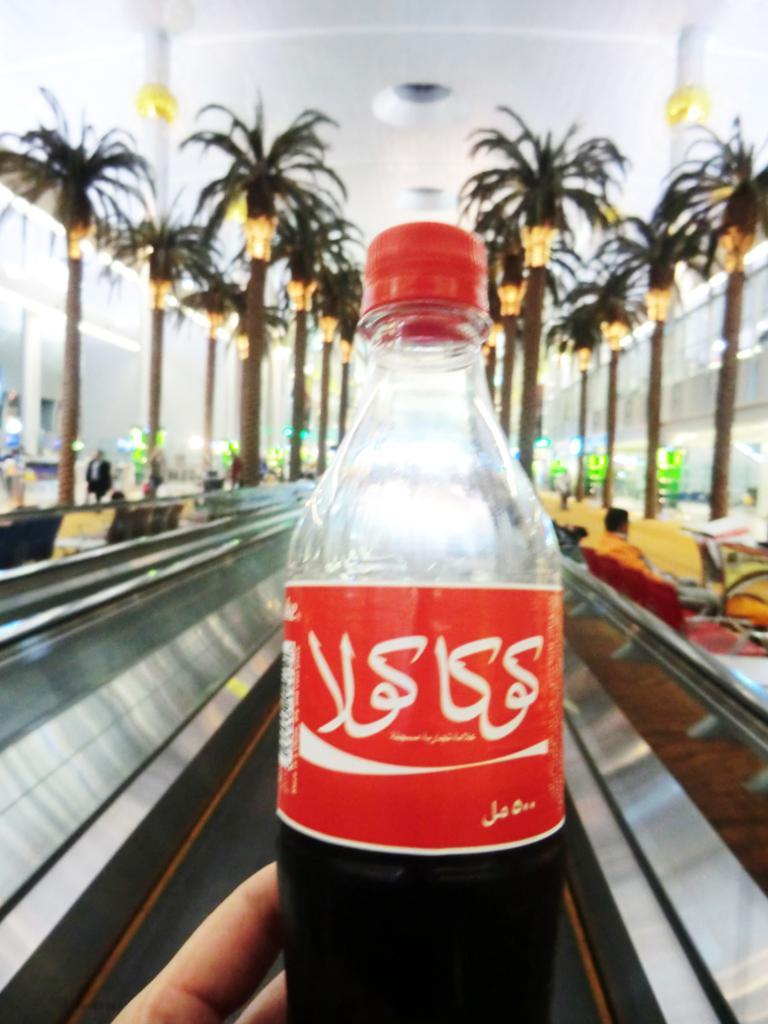Can you describe this image briefly? There is a bottle holding with hand. On the background we can see trees,light,wall. 